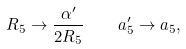Convert formula to latex. <formula><loc_0><loc_0><loc_500><loc_500>R _ { 5 } \rightarrow \frac { \alpha ^ { \prime } } { 2 R _ { 5 } } \quad a _ { 5 } ^ { \prime } \rightarrow a _ { 5 } ,</formula> 